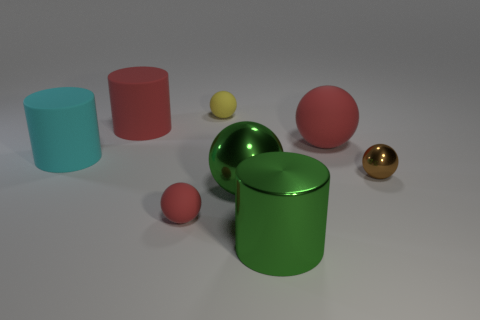What number of other objects are there of the same color as the big matte ball?
Offer a very short reply. 2. Is the size of the red sphere behind the tiny brown metal sphere the same as the red sphere to the left of the tiny yellow matte thing?
Provide a succinct answer. No. Are there an equal number of red things on the left side of the cyan cylinder and red matte things behind the large red cylinder?
Your answer should be very brief. Yes. Are there any other things that are made of the same material as the green ball?
Your answer should be very brief. Yes. There is a brown ball; is it the same size as the rubber sphere to the left of the tiny yellow rubber thing?
Ensure brevity in your answer.  Yes. What is the tiny object that is to the right of the big cylinder that is in front of the small brown thing made of?
Give a very brief answer. Metal. Are there an equal number of green spheres behind the cyan object and large red shiny things?
Provide a succinct answer. Yes. There is a sphere that is both to the right of the tiny yellow matte sphere and to the left of the green metal cylinder; what size is it?
Provide a succinct answer. Large. There is a rubber cylinder to the right of the big cyan matte cylinder behind the green cylinder; what is its color?
Provide a succinct answer. Red. What number of gray objects are big metal balls or tiny rubber balls?
Your answer should be compact. 0. 